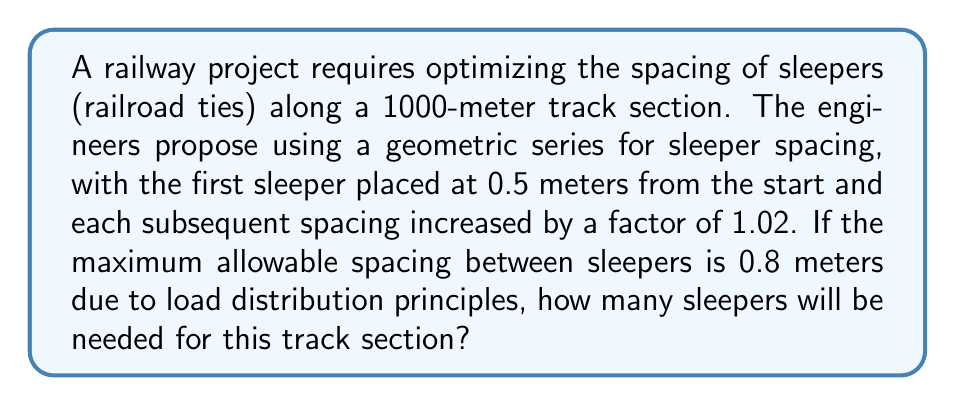What is the answer to this math problem? To solve this problem, we need to use the properties of geometric series and the given constraints. Let's approach this step-by-step:

1) Let's define our geometric series:
   $a_1 = 0.5$ (first term)
   $r = 1.02$ (common ratio)

2) The general term of a geometric series is given by:
   $a_n = a_1 * r^{n-1}$

3) We need to find the largest $n$ such that $a_n \leq 0.8$ (maximum allowable spacing)

4) We can set up the inequality:
   $0.5 * 1.02^{n-1} \leq 0.8$

5) Solving for $n$:
   $1.02^{n-1} \leq 1.6$
   $\ln(1.02^{n-1}) \leq \ln(1.6)$
   $(n-1)\ln(1.02) \leq \ln(1.6)$
   $n-1 \leq \frac{\ln(1.6)}{\ln(1.02)}$
   $n \leq \frac{\ln(1.6)}{\ln(1.02)} + 1 \approx 24.48$

6) Since $n$ must be an integer, the maximum number of terms in our series before exceeding 0.8 meters is 24.

7) Now, we need to find how many of these 24-term series fit within 1000 meters. Let's calculate the sum of this 24-term series:

   $S_{24} = a_1\frac{1-r^{24}}{1-r} = 0.5\frac{1-1.02^{24}}{1-1.02} \approx 14.05$ meters

8) The number of complete series that fit in 1000 meters:
   $\lfloor\frac{1000}{14.05}\rfloor = 71$

9) This accounts for $71 * 24 = 1704$ sleepers

10) For the remaining distance:
    $1000 - (71 * 14.05) \approx 2.45$ meters

11) We can fit 4 more sleepers in this remaining distance (0.5 + 0.51 + 0.5202 + 0.530604 = 2.060804 < 2.45)

Therefore, the total number of sleepers needed is 1704 + 4 = 1708.
Answer: 1708 sleepers 